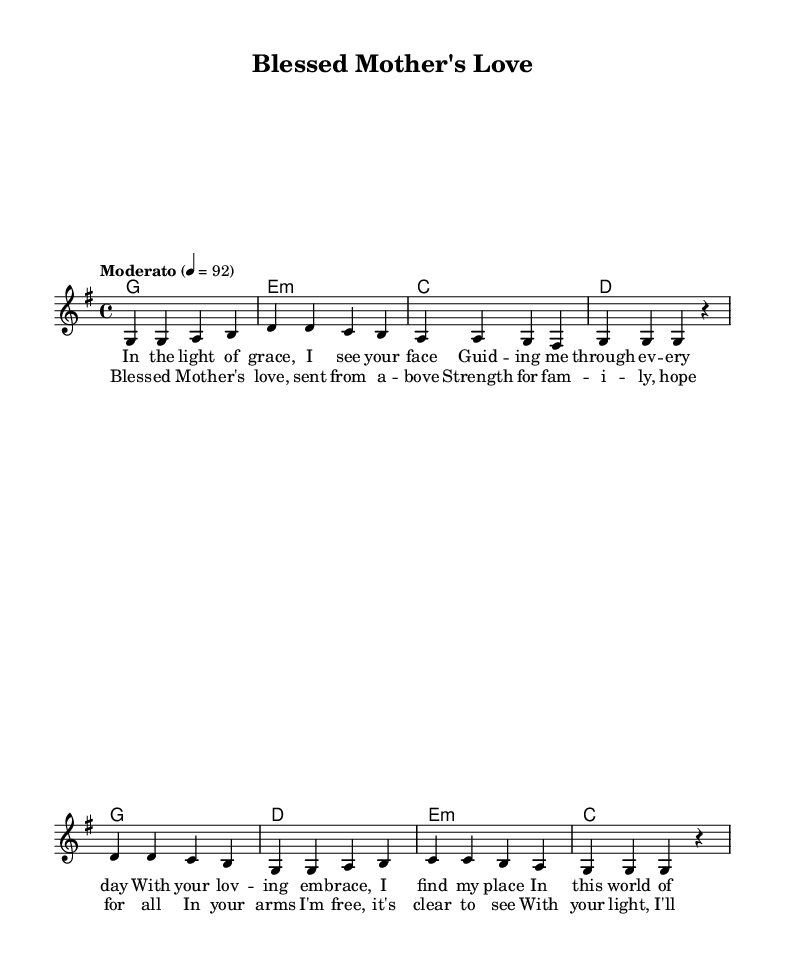What is the key signature of this music? The key signature is G major, which has one sharp (F#). This can be determined by looking at the beginning of the music score where the key signature is indicated.
Answer: G major What is the time signature of this music? The time signature is 4/4 as indicated at the beginning of the music score. This means there are four beats in each measure and the quarter note gets one beat.
Answer: 4/4 What is the tempo marking for this piece? The tempo marking is "Moderato," which suggests a moderate pace. This is usually printed at the start of the score to guide the performer on how fast to play the piece.
Answer: Moderato What chord follows the G major chord in the chorus? The chord that follows the G major chord in the chorus is D major. This can be found by analyzing the chord progression as indicated in the harmonies section.
Answer: D What is the main theme of the lyrics in the chorus? The main theme of the lyrics in the chorus revolves around maternal love and support, emphasizing hope and strength provided by a mother. This theme is derived from the words used in the lyrics presented under the melody.
Answer: Maternal love How does the melody start in the verse? The melody starts with a G note in the verse, which is evident by looking at the first note in the melody section of the score.
Answer: G 